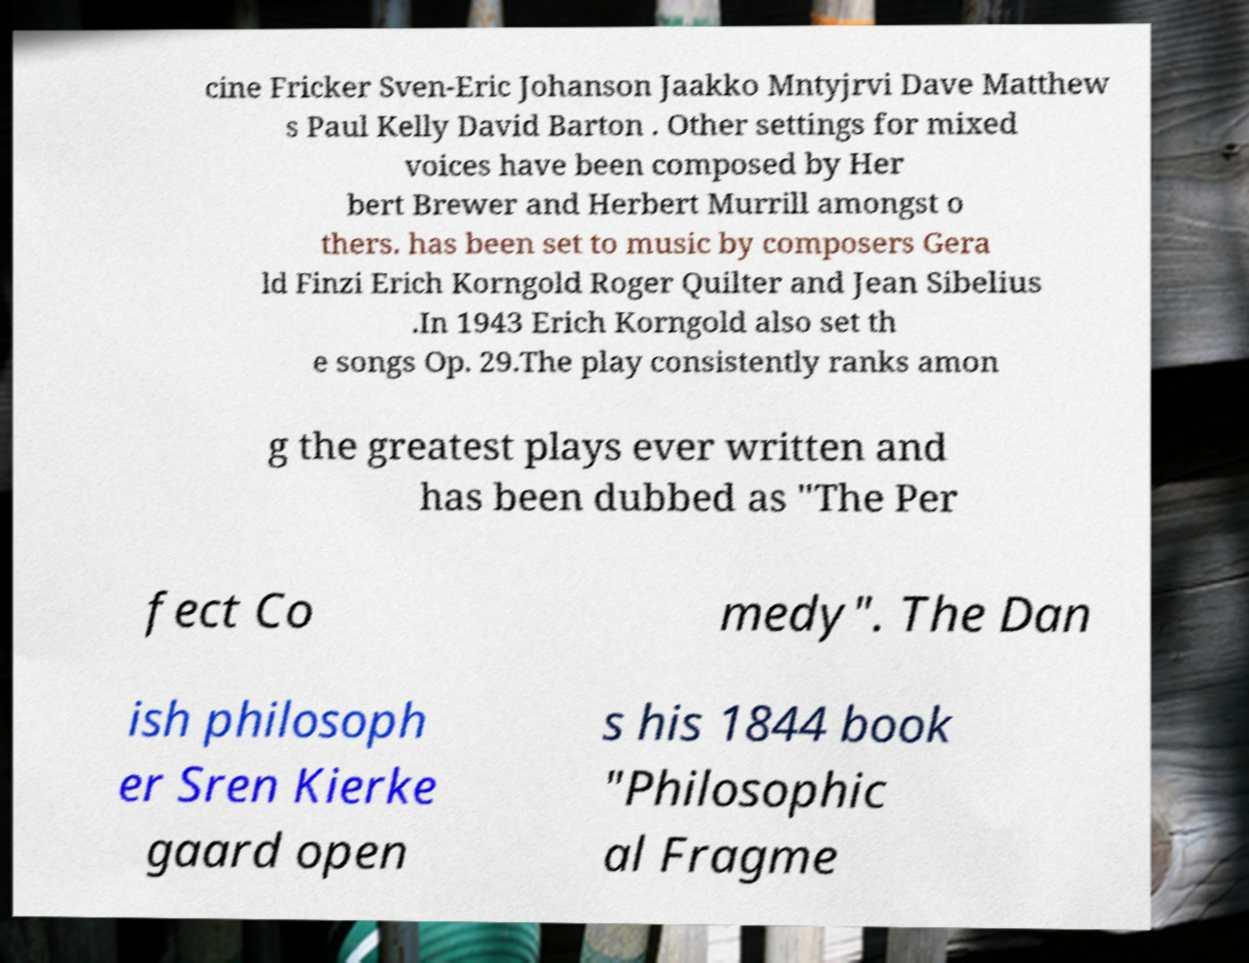Could you extract and type out the text from this image? cine Fricker Sven-Eric Johanson Jaakko Mntyjrvi Dave Matthew s Paul Kelly David Barton . Other settings for mixed voices have been composed by Her bert Brewer and Herbert Murrill amongst o thers. has been set to music by composers Gera ld Finzi Erich Korngold Roger Quilter and Jean Sibelius .In 1943 Erich Korngold also set th e songs Op. 29.The play consistently ranks amon g the greatest plays ever written and has been dubbed as "The Per fect Co medy". The Dan ish philosoph er Sren Kierke gaard open s his 1844 book "Philosophic al Fragme 